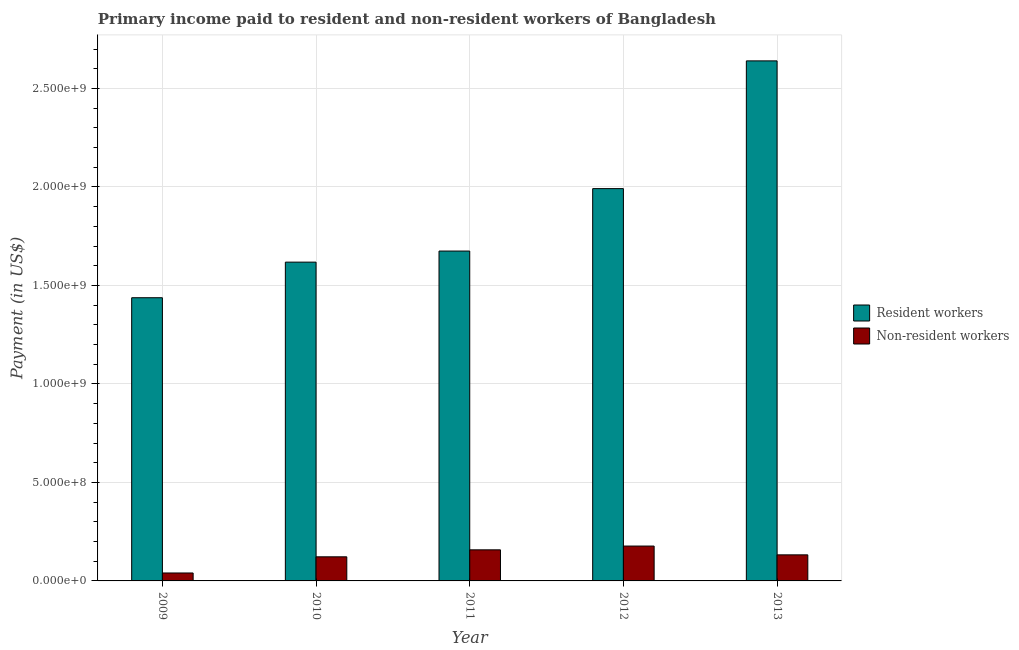Are the number of bars on each tick of the X-axis equal?
Make the answer very short. Yes. In how many cases, is the number of bars for a given year not equal to the number of legend labels?
Provide a succinct answer. 0. What is the payment made to non-resident workers in 2010?
Provide a succinct answer. 1.22e+08. Across all years, what is the maximum payment made to non-resident workers?
Provide a succinct answer. 1.77e+08. Across all years, what is the minimum payment made to non-resident workers?
Keep it short and to the point. 4.03e+07. In which year was the payment made to resident workers maximum?
Provide a succinct answer. 2013. What is the total payment made to non-resident workers in the graph?
Your answer should be compact. 6.30e+08. What is the difference between the payment made to non-resident workers in 2009 and that in 2010?
Ensure brevity in your answer.  -8.21e+07. What is the difference between the payment made to non-resident workers in 2012 and the payment made to resident workers in 2010?
Provide a short and direct response. 5.46e+07. What is the average payment made to resident workers per year?
Your response must be concise. 1.87e+09. What is the ratio of the payment made to non-resident workers in 2010 to that in 2012?
Your response must be concise. 0.69. Is the payment made to non-resident workers in 2009 less than that in 2012?
Offer a very short reply. Yes. What is the difference between the highest and the second highest payment made to resident workers?
Provide a short and direct response. 6.49e+08. What is the difference between the highest and the lowest payment made to resident workers?
Provide a short and direct response. 1.20e+09. What does the 1st bar from the left in 2013 represents?
Your answer should be compact. Resident workers. What does the 2nd bar from the right in 2013 represents?
Offer a very short reply. Resident workers. How many years are there in the graph?
Give a very brief answer. 5. Are the values on the major ticks of Y-axis written in scientific E-notation?
Offer a terse response. Yes. Where does the legend appear in the graph?
Provide a short and direct response. Center right. How many legend labels are there?
Make the answer very short. 2. What is the title of the graph?
Your answer should be very brief. Primary income paid to resident and non-resident workers of Bangladesh. What is the label or title of the X-axis?
Your response must be concise. Year. What is the label or title of the Y-axis?
Your answer should be very brief. Payment (in US$). What is the Payment (in US$) of Resident workers in 2009?
Make the answer very short. 1.44e+09. What is the Payment (in US$) of Non-resident workers in 2009?
Offer a terse response. 4.03e+07. What is the Payment (in US$) in Resident workers in 2010?
Ensure brevity in your answer.  1.62e+09. What is the Payment (in US$) in Non-resident workers in 2010?
Your response must be concise. 1.22e+08. What is the Payment (in US$) in Resident workers in 2011?
Your answer should be very brief. 1.67e+09. What is the Payment (in US$) of Non-resident workers in 2011?
Offer a very short reply. 1.58e+08. What is the Payment (in US$) in Resident workers in 2012?
Offer a terse response. 1.99e+09. What is the Payment (in US$) of Non-resident workers in 2012?
Ensure brevity in your answer.  1.77e+08. What is the Payment (in US$) in Resident workers in 2013?
Give a very brief answer. 2.64e+09. What is the Payment (in US$) of Non-resident workers in 2013?
Give a very brief answer. 1.32e+08. Across all years, what is the maximum Payment (in US$) in Resident workers?
Ensure brevity in your answer.  2.64e+09. Across all years, what is the maximum Payment (in US$) of Non-resident workers?
Your answer should be very brief. 1.77e+08. Across all years, what is the minimum Payment (in US$) of Resident workers?
Offer a terse response. 1.44e+09. Across all years, what is the minimum Payment (in US$) of Non-resident workers?
Provide a succinct answer. 4.03e+07. What is the total Payment (in US$) in Resident workers in the graph?
Your answer should be very brief. 9.36e+09. What is the total Payment (in US$) of Non-resident workers in the graph?
Offer a terse response. 6.30e+08. What is the difference between the Payment (in US$) of Resident workers in 2009 and that in 2010?
Ensure brevity in your answer.  -1.81e+08. What is the difference between the Payment (in US$) of Non-resident workers in 2009 and that in 2010?
Offer a terse response. -8.21e+07. What is the difference between the Payment (in US$) in Resident workers in 2009 and that in 2011?
Your answer should be compact. -2.37e+08. What is the difference between the Payment (in US$) of Non-resident workers in 2009 and that in 2011?
Ensure brevity in your answer.  -1.18e+08. What is the difference between the Payment (in US$) in Resident workers in 2009 and that in 2012?
Your response must be concise. -5.54e+08. What is the difference between the Payment (in US$) of Non-resident workers in 2009 and that in 2012?
Offer a terse response. -1.37e+08. What is the difference between the Payment (in US$) in Resident workers in 2009 and that in 2013?
Your response must be concise. -1.20e+09. What is the difference between the Payment (in US$) of Non-resident workers in 2009 and that in 2013?
Provide a succinct answer. -9.20e+07. What is the difference between the Payment (in US$) of Resident workers in 2010 and that in 2011?
Make the answer very short. -5.62e+07. What is the difference between the Payment (in US$) of Non-resident workers in 2010 and that in 2011?
Your answer should be very brief. -3.55e+07. What is the difference between the Payment (in US$) in Resident workers in 2010 and that in 2012?
Your answer should be very brief. -3.73e+08. What is the difference between the Payment (in US$) of Non-resident workers in 2010 and that in 2012?
Your answer should be compact. -5.46e+07. What is the difference between the Payment (in US$) in Resident workers in 2010 and that in 2013?
Provide a succinct answer. -1.02e+09. What is the difference between the Payment (in US$) of Non-resident workers in 2010 and that in 2013?
Give a very brief answer. -9.95e+06. What is the difference between the Payment (in US$) in Resident workers in 2011 and that in 2012?
Offer a terse response. -3.17e+08. What is the difference between the Payment (in US$) in Non-resident workers in 2011 and that in 2012?
Your answer should be very brief. -1.91e+07. What is the difference between the Payment (in US$) of Resident workers in 2011 and that in 2013?
Your answer should be very brief. -9.65e+08. What is the difference between the Payment (in US$) of Non-resident workers in 2011 and that in 2013?
Your answer should be very brief. 2.55e+07. What is the difference between the Payment (in US$) in Resident workers in 2012 and that in 2013?
Keep it short and to the point. -6.49e+08. What is the difference between the Payment (in US$) in Non-resident workers in 2012 and that in 2013?
Ensure brevity in your answer.  4.46e+07. What is the difference between the Payment (in US$) in Resident workers in 2009 and the Payment (in US$) in Non-resident workers in 2010?
Give a very brief answer. 1.32e+09. What is the difference between the Payment (in US$) of Resident workers in 2009 and the Payment (in US$) of Non-resident workers in 2011?
Give a very brief answer. 1.28e+09. What is the difference between the Payment (in US$) in Resident workers in 2009 and the Payment (in US$) in Non-resident workers in 2012?
Give a very brief answer. 1.26e+09. What is the difference between the Payment (in US$) of Resident workers in 2009 and the Payment (in US$) of Non-resident workers in 2013?
Keep it short and to the point. 1.31e+09. What is the difference between the Payment (in US$) of Resident workers in 2010 and the Payment (in US$) of Non-resident workers in 2011?
Your answer should be very brief. 1.46e+09. What is the difference between the Payment (in US$) of Resident workers in 2010 and the Payment (in US$) of Non-resident workers in 2012?
Make the answer very short. 1.44e+09. What is the difference between the Payment (in US$) of Resident workers in 2010 and the Payment (in US$) of Non-resident workers in 2013?
Your answer should be compact. 1.49e+09. What is the difference between the Payment (in US$) in Resident workers in 2011 and the Payment (in US$) in Non-resident workers in 2012?
Your response must be concise. 1.50e+09. What is the difference between the Payment (in US$) in Resident workers in 2011 and the Payment (in US$) in Non-resident workers in 2013?
Offer a very short reply. 1.54e+09. What is the difference between the Payment (in US$) in Resident workers in 2012 and the Payment (in US$) in Non-resident workers in 2013?
Your answer should be compact. 1.86e+09. What is the average Payment (in US$) of Resident workers per year?
Offer a terse response. 1.87e+09. What is the average Payment (in US$) of Non-resident workers per year?
Offer a terse response. 1.26e+08. In the year 2009, what is the difference between the Payment (in US$) of Resident workers and Payment (in US$) of Non-resident workers?
Make the answer very short. 1.40e+09. In the year 2010, what is the difference between the Payment (in US$) of Resident workers and Payment (in US$) of Non-resident workers?
Ensure brevity in your answer.  1.50e+09. In the year 2011, what is the difference between the Payment (in US$) in Resident workers and Payment (in US$) in Non-resident workers?
Offer a very short reply. 1.52e+09. In the year 2012, what is the difference between the Payment (in US$) of Resident workers and Payment (in US$) of Non-resident workers?
Make the answer very short. 1.81e+09. In the year 2013, what is the difference between the Payment (in US$) of Resident workers and Payment (in US$) of Non-resident workers?
Your answer should be very brief. 2.51e+09. What is the ratio of the Payment (in US$) of Resident workers in 2009 to that in 2010?
Your answer should be compact. 0.89. What is the ratio of the Payment (in US$) of Non-resident workers in 2009 to that in 2010?
Offer a terse response. 0.33. What is the ratio of the Payment (in US$) in Resident workers in 2009 to that in 2011?
Ensure brevity in your answer.  0.86. What is the ratio of the Payment (in US$) of Non-resident workers in 2009 to that in 2011?
Ensure brevity in your answer.  0.26. What is the ratio of the Payment (in US$) in Resident workers in 2009 to that in 2012?
Make the answer very short. 0.72. What is the ratio of the Payment (in US$) in Non-resident workers in 2009 to that in 2012?
Make the answer very short. 0.23. What is the ratio of the Payment (in US$) in Resident workers in 2009 to that in 2013?
Offer a very short reply. 0.54. What is the ratio of the Payment (in US$) in Non-resident workers in 2009 to that in 2013?
Your response must be concise. 0.3. What is the ratio of the Payment (in US$) in Resident workers in 2010 to that in 2011?
Your response must be concise. 0.97. What is the ratio of the Payment (in US$) of Non-resident workers in 2010 to that in 2011?
Your answer should be very brief. 0.78. What is the ratio of the Payment (in US$) in Resident workers in 2010 to that in 2012?
Ensure brevity in your answer.  0.81. What is the ratio of the Payment (in US$) of Non-resident workers in 2010 to that in 2012?
Offer a terse response. 0.69. What is the ratio of the Payment (in US$) of Resident workers in 2010 to that in 2013?
Give a very brief answer. 0.61. What is the ratio of the Payment (in US$) of Non-resident workers in 2010 to that in 2013?
Provide a short and direct response. 0.92. What is the ratio of the Payment (in US$) in Resident workers in 2011 to that in 2012?
Keep it short and to the point. 0.84. What is the ratio of the Payment (in US$) of Non-resident workers in 2011 to that in 2012?
Provide a short and direct response. 0.89. What is the ratio of the Payment (in US$) of Resident workers in 2011 to that in 2013?
Offer a terse response. 0.63. What is the ratio of the Payment (in US$) in Non-resident workers in 2011 to that in 2013?
Offer a terse response. 1.19. What is the ratio of the Payment (in US$) in Resident workers in 2012 to that in 2013?
Your response must be concise. 0.75. What is the ratio of the Payment (in US$) in Non-resident workers in 2012 to that in 2013?
Your response must be concise. 1.34. What is the difference between the highest and the second highest Payment (in US$) in Resident workers?
Provide a succinct answer. 6.49e+08. What is the difference between the highest and the second highest Payment (in US$) in Non-resident workers?
Offer a terse response. 1.91e+07. What is the difference between the highest and the lowest Payment (in US$) in Resident workers?
Give a very brief answer. 1.20e+09. What is the difference between the highest and the lowest Payment (in US$) of Non-resident workers?
Keep it short and to the point. 1.37e+08. 